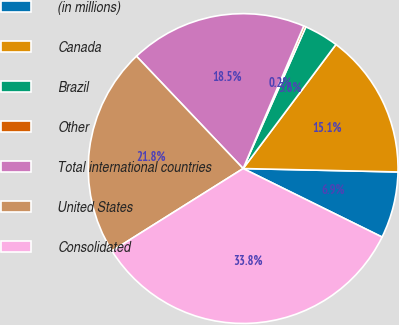Convert chart. <chart><loc_0><loc_0><loc_500><loc_500><pie_chart><fcel>(in millions)<fcel>Canada<fcel>Brazil<fcel>Other<fcel>Total international countries<fcel>United States<fcel>Consolidated<nl><fcel>6.94%<fcel>15.13%<fcel>3.59%<fcel>0.23%<fcel>18.49%<fcel>21.84%<fcel>33.78%<nl></chart> 